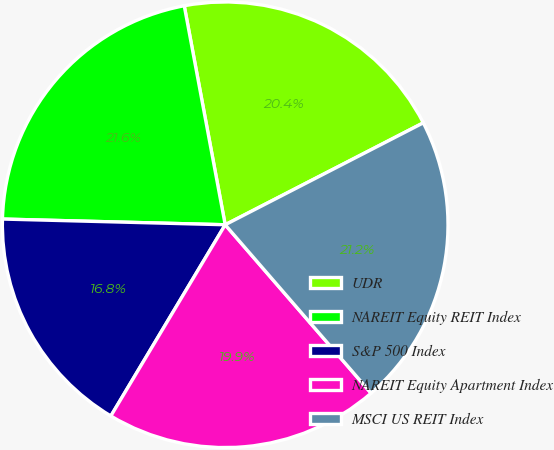Convert chart to OTSL. <chart><loc_0><loc_0><loc_500><loc_500><pie_chart><fcel>UDR<fcel>NAREIT Equity REIT Index<fcel>S&P 500 Index<fcel>NAREIT Equity Apartment Index<fcel>MSCI US REIT Index<nl><fcel>20.38%<fcel>21.65%<fcel>16.83%<fcel>19.94%<fcel>21.2%<nl></chart> 